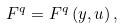Convert formula to latex. <formula><loc_0><loc_0><loc_500><loc_500>F ^ { q } = F ^ { q } \left ( y , u \right ) ,</formula> 